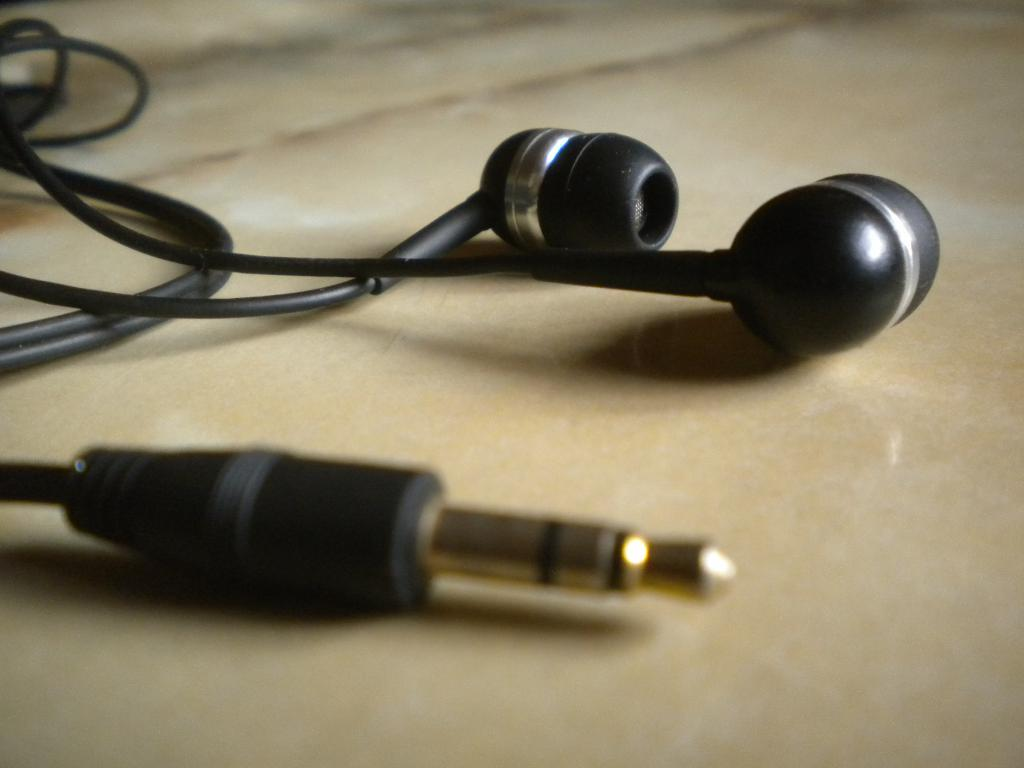What type of audio accessory is present in the image? There are wired earphones in the image. Where are the earphones located in the image? The earphones are in the front of the image. What can be seen at the bottom of the image? There is a floor visible at the bottom of the image. Can you tell me the opinion of the owl sitting on the horse in the image? There is no owl or horse present in the image, so it is not possible to determine the opinion of an owl in this context. 